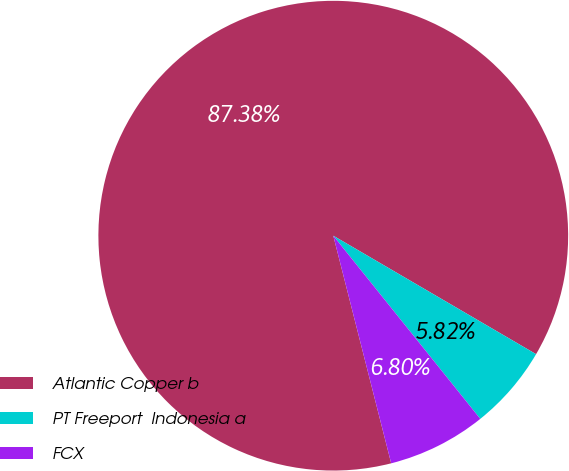Convert chart to OTSL. <chart><loc_0><loc_0><loc_500><loc_500><pie_chart><fcel>Atlantic Copper b<fcel>PT Freeport  Indonesia a<fcel>FCX<nl><fcel>87.38%<fcel>5.82%<fcel>6.8%<nl></chart> 